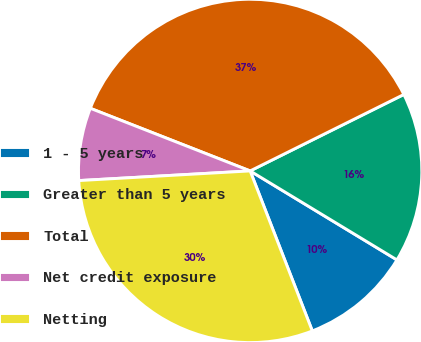<chart> <loc_0><loc_0><loc_500><loc_500><pie_chart><fcel>1 - 5 years<fcel>Greater than 5 years<fcel>Total<fcel>Net credit exposure<fcel>Netting<nl><fcel>10.43%<fcel>16.02%<fcel>36.71%<fcel>6.84%<fcel>30.0%<nl></chart> 